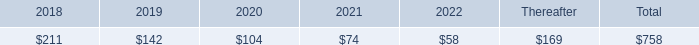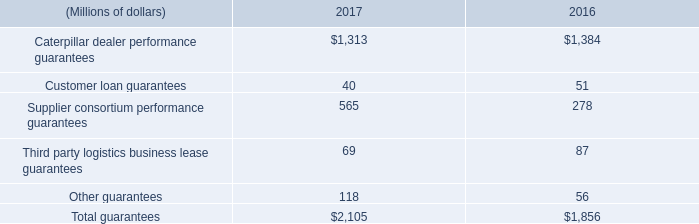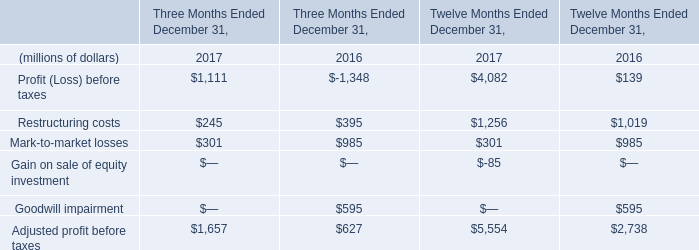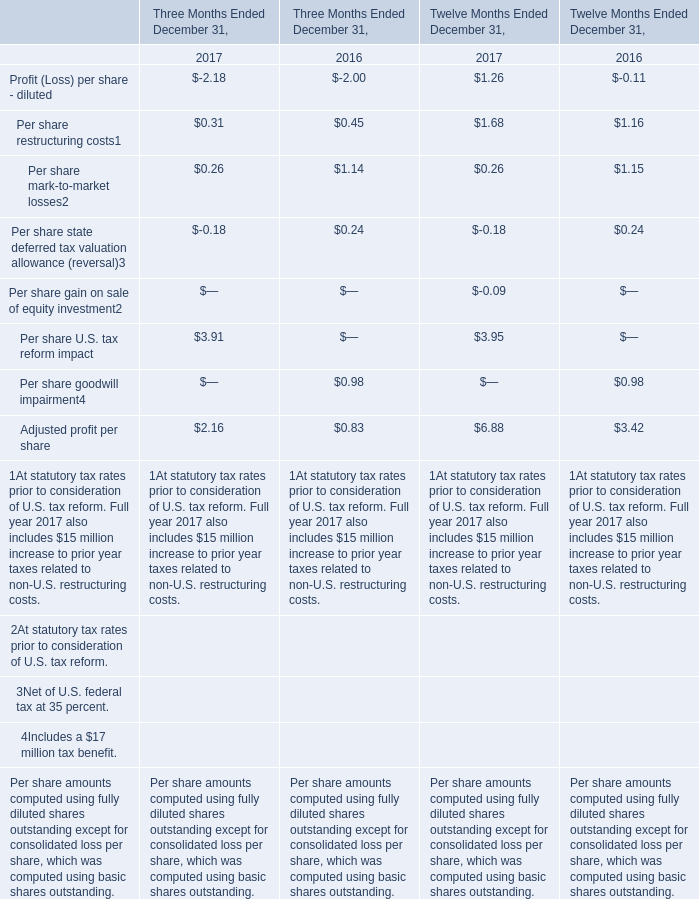In which years is Per share restructuring costs greater than Profit (Loss) per share - diluted (for Twelve Months Ended December 31)? 
Answer: 2016; 2017. 